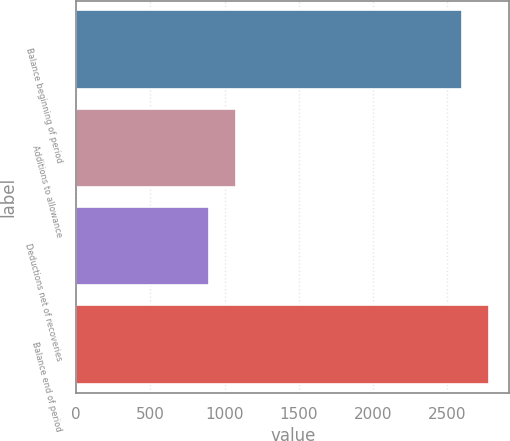<chart> <loc_0><loc_0><loc_500><loc_500><bar_chart><fcel>Balance beginning of period<fcel>Additions to allowance<fcel>Deductions net of recoveries<fcel>Balance end of period<nl><fcel>2600<fcel>1075.5<fcel>895<fcel>2780.5<nl></chart> 